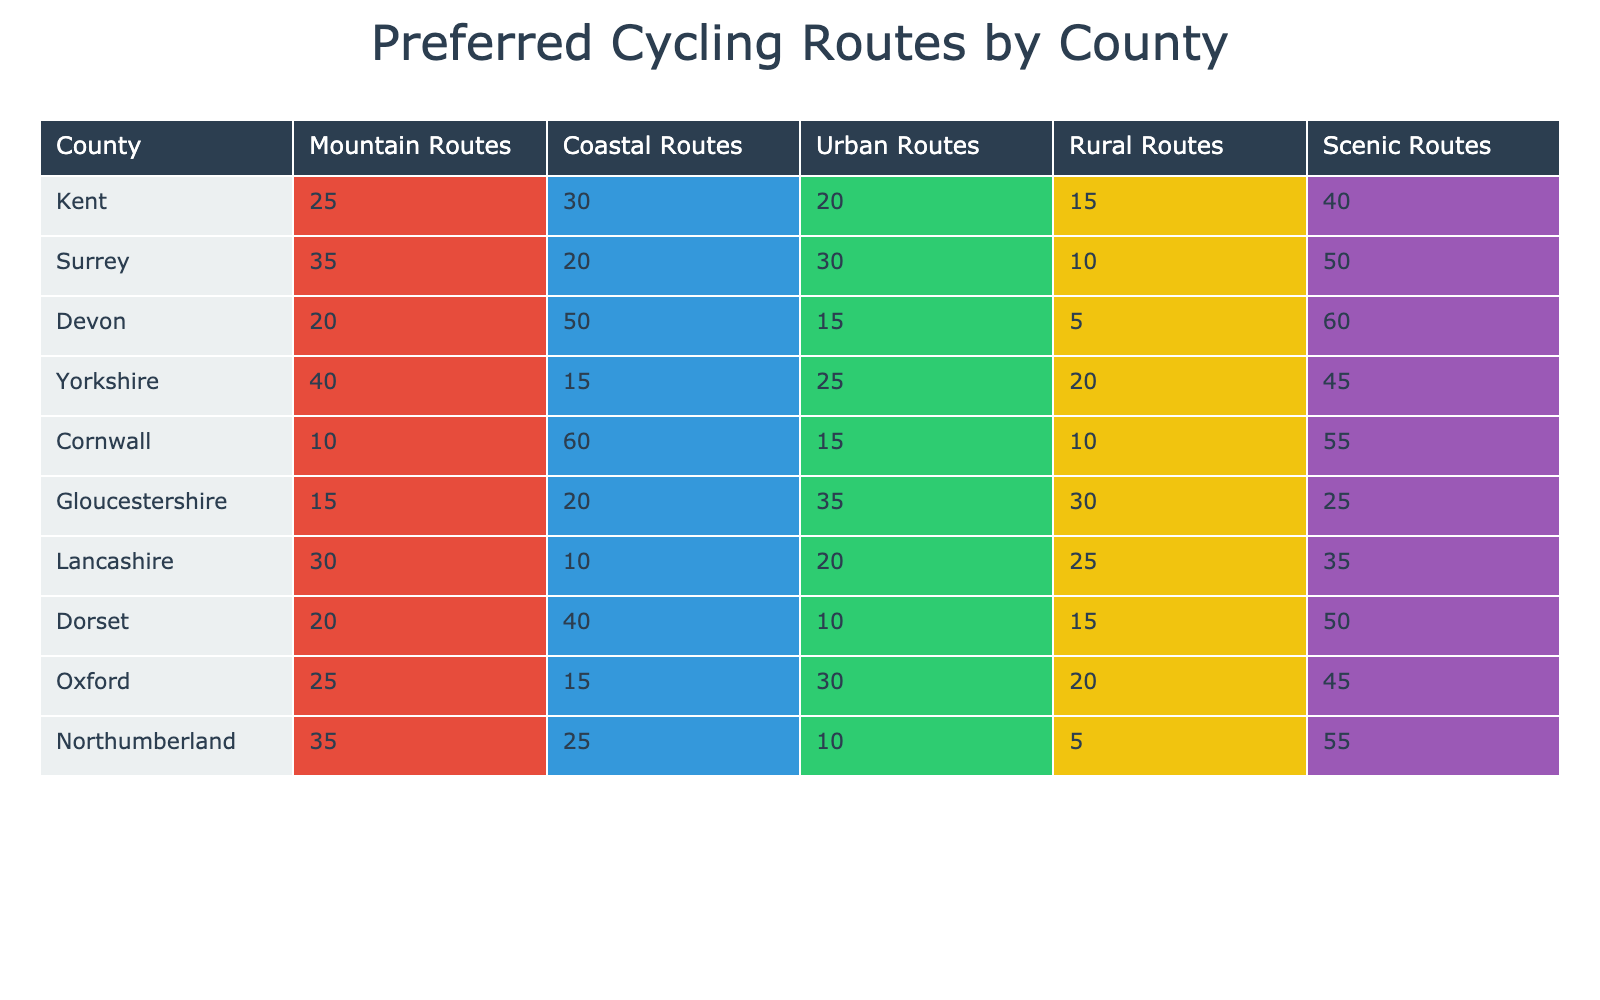What is the highest number of Mountain Routes preferred in a single county? Looking at the Mountain Routes column, the highest value is 40, which corresponds to Yorkshire.
Answer: 40 Which county shows the lowest preference for Coastal Routes? In the Coastal Routes column, the smallest value is 10, seen in Lancashire.
Answer: Lancashire How many more participants preferred Scenic Routes in Devon compared to Coastal Routes? Devon has 60 Scenic Routes and 50 Coastal Routes. The difference is 60 - 50 = 10.
Answer: 10 Is it true that Northumberland has more participants preferring Urban Routes than Dorset? Northumberland's Urban Routes value is 10, which is less than Dorset's, which has 10. Therefore, the statement is false.
Answer: No What is the total number of participants preferring Rural Routes across all counties? By summing the Rural Routes values: 15 (Kent) + 10 (Surrey) + 5 (Devon) + 20 (Yorkshire) + 10 (Cornwall) + 30 (Gloucestershire) + 25 (Lancashire) + 15 (Dorset) + 20 (Oxford) + 5 (Northumberland) = 130.
Answer: 130 Which county has the highest total number of participants across all route types? To find the county with the highest total, sum all route types for each county and compare. Surrey totals 50 + 35 + 30 + 10 + 50 = 175, which is the highest total.
Answer: Surrey How many counties have more than 40 participants preferring Scenic Routes? Looking at the Scenic Routes column, Kent, Surrey, Devon, Cornwall, and Northumberland all have 40 or more. That's 5 counties.
Answer: 5 Calculate the average number of Coastal Routes preferred across all counties. The Coastal Routes values are: 30, 20, 50, 15, 60, 20, 10, 40, 15, and 25. The total is 65, divided by 10 counties gives an average of 38.
Answer: 38 Which two counties have the same preference for Urban Routes? Both Yorkshire and Cornwall have 15 participants preferring Urban Routes.
Answer: Yorkshire, Cornwall 